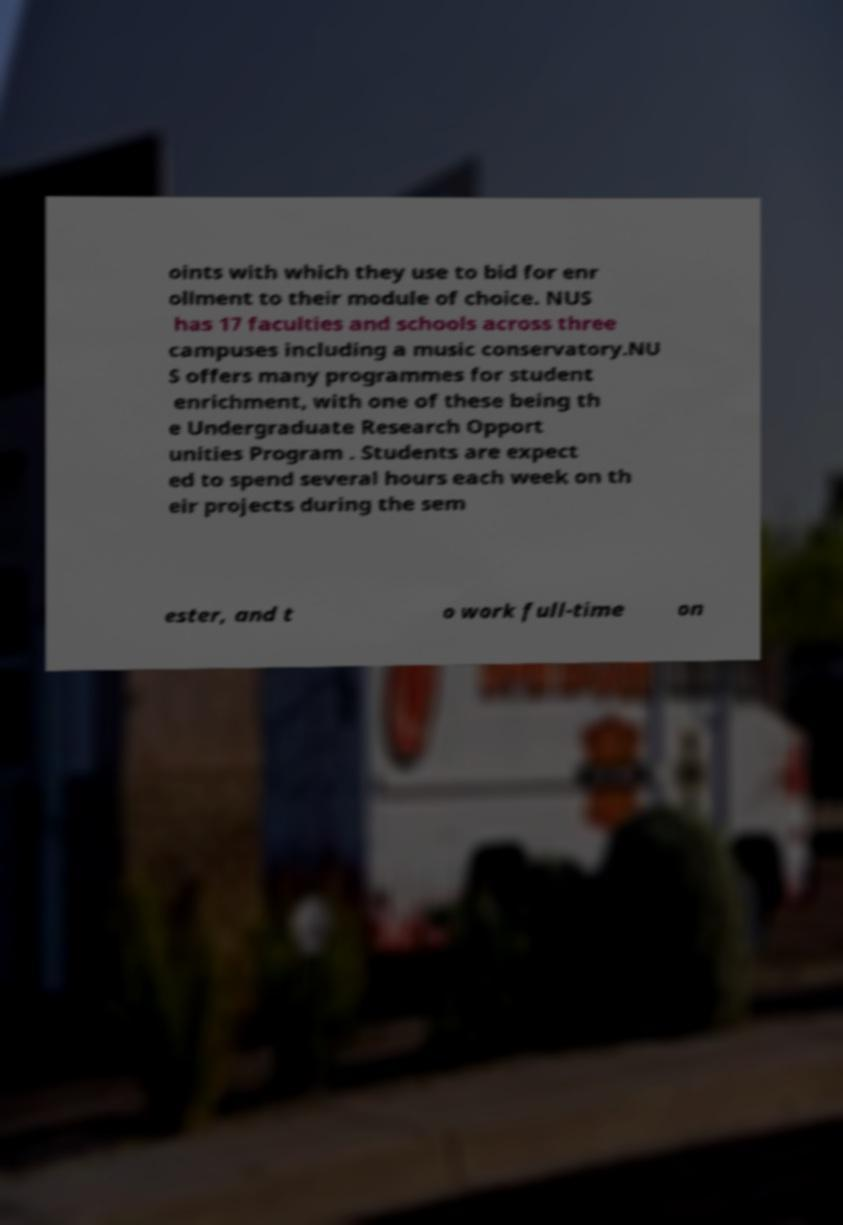Please identify and transcribe the text found in this image. oints with which they use to bid for enr ollment to their module of choice. NUS has 17 faculties and schools across three campuses including a music conservatory.NU S offers many programmes for student enrichment, with one of these being th e Undergraduate Research Opport unities Program . Students are expect ed to spend several hours each week on th eir projects during the sem ester, and t o work full-time on 